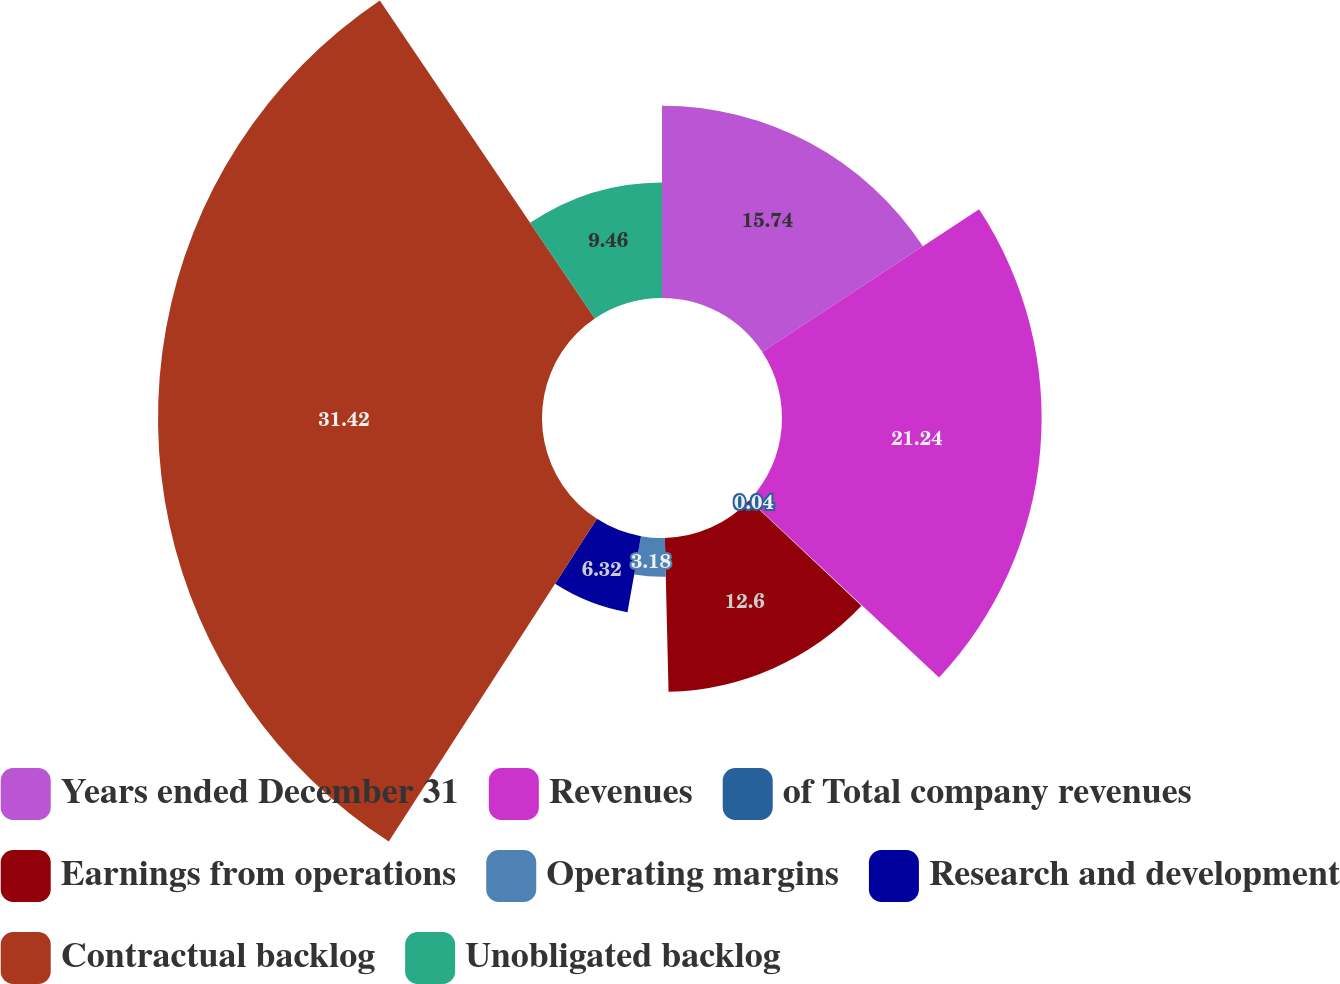Convert chart. <chart><loc_0><loc_0><loc_500><loc_500><pie_chart><fcel>Years ended December 31<fcel>Revenues<fcel>of Total company revenues<fcel>Earnings from operations<fcel>Operating margins<fcel>Research and development<fcel>Contractual backlog<fcel>Unobligated backlog<nl><fcel>15.74%<fcel>21.25%<fcel>0.04%<fcel>12.6%<fcel>3.18%<fcel>6.32%<fcel>31.43%<fcel>9.46%<nl></chart> 